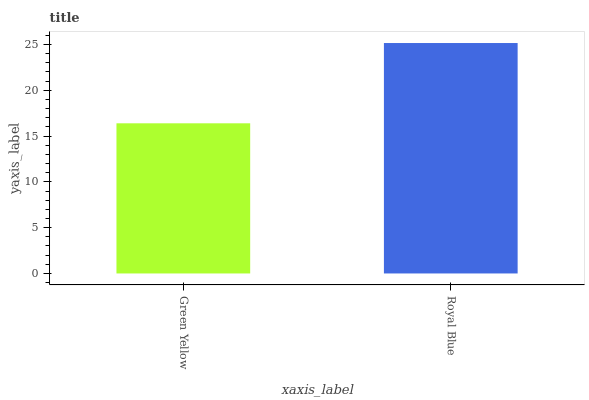Is Green Yellow the minimum?
Answer yes or no. Yes. Is Royal Blue the maximum?
Answer yes or no. Yes. Is Royal Blue the minimum?
Answer yes or no. No. Is Royal Blue greater than Green Yellow?
Answer yes or no. Yes. Is Green Yellow less than Royal Blue?
Answer yes or no. Yes. Is Green Yellow greater than Royal Blue?
Answer yes or no. No. Is Royal Blue less than Green Yellow?
Answer yes or no. No. Is Royal Blue the high median?
Answer yes or no. Yes. Is Green Yellow the low median?
Answer yes or no. Yes. Is Green Yellow the high median?
Answer yes or no. No. Is Royal Blue the low median?
Answer yes or no. No. 